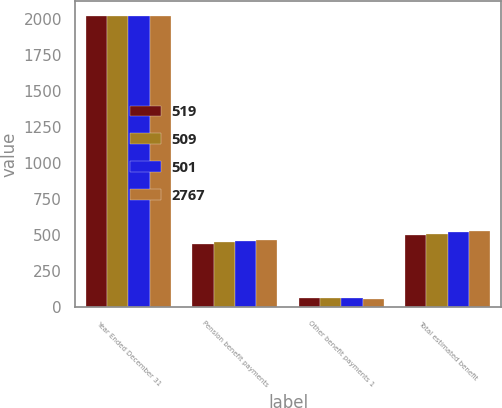Convert chart. <chart><loc_0><loc_0><loc_500><loc_500><stacked_bar_chart><ecel><fcel>Year Ended December 31<fcel>Pension benefit payments<fcel>Other benefit payments 1<fcel>Total estimated benefit<nl><fcel>519<fcel>2019<fcel>439<fcel>62<fcel>501<nl><fcel>509<fcel>2020<fcel>448<fcel>61<fcel>509<nl><fcel>501<fcel>2021<fcel>460<fcel>59<fcel>519<nl><fcel>2767<fcel>2022<fcel>468<fcel>57<fcel>525<nl></chart> 